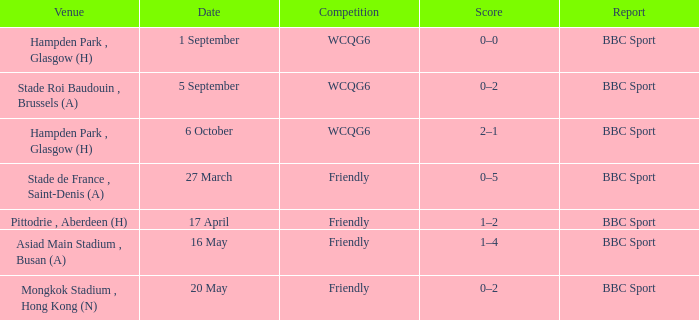What was the score of the game on 1 september? 0–0. 